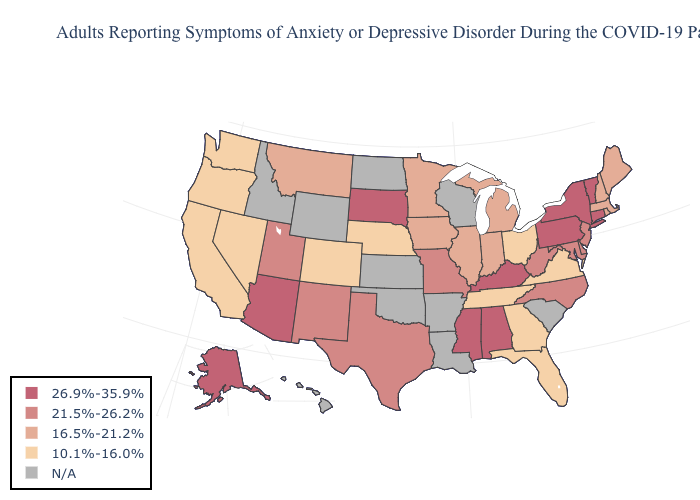Is the legend a continuous bar?
Write a very short answer. No. What is the value of Ohio?
Write a very short answer. 10.1%-16.0%. Does the map have missing data?
Quick response, please. Yes. What is the value of Minnesota?
Short answer required. 16.5%-21.2%. What is the value of Oregon?
Quick response, please. 10.1%-16.0%. Which states have the lowest value in the MidWest?
Answer briefly. Nebraska, Ohio. Among the states that border Arizona , which have the lowest value?
Short answer required. California, Colorado, Nevada. How many symbols are there in the legend?
Give a very brief answer. 5. Name the states that have a value in the range 26.9%-35.9%?
Keep it brief. Alabama, Alaska, Arizona, Connecticut, Kentucky, Mississippi, New York, Pennsylvania, South Dakota, Vermont. Does South Dakota have the lowest value in the MidWest?
Answer briefly. No. Does Indiana have the highest value in the USA?
Short answer required. No. What is the value of Indiana?
Give a very brief answer. 16.5%-21.2%. 